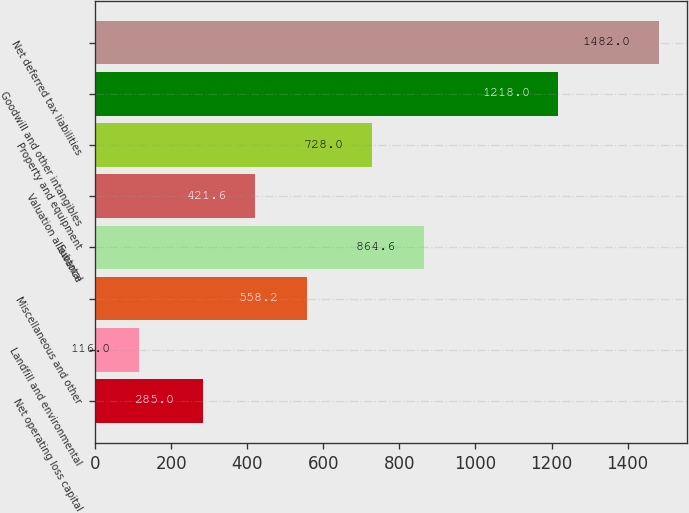<chart> <loc_0><loc_0><loc_500><loc_500><bar_chart><fcel>Net operating loss capital<fcel>Landfill and environmental<fcel>Miscellaneous and other<fcel>Subtotal<fcel>Valuation allowance<fcel>Property and equipment<fcel>Goodwill and other intangibles<fcel>Net deferred tax liabilities<nl><fcel>285<fcel>116<fcel>558.2<fcel>864.6<fcel>421.6<fcel>728<fcel>1218<fcel>1482<nl></chart> 